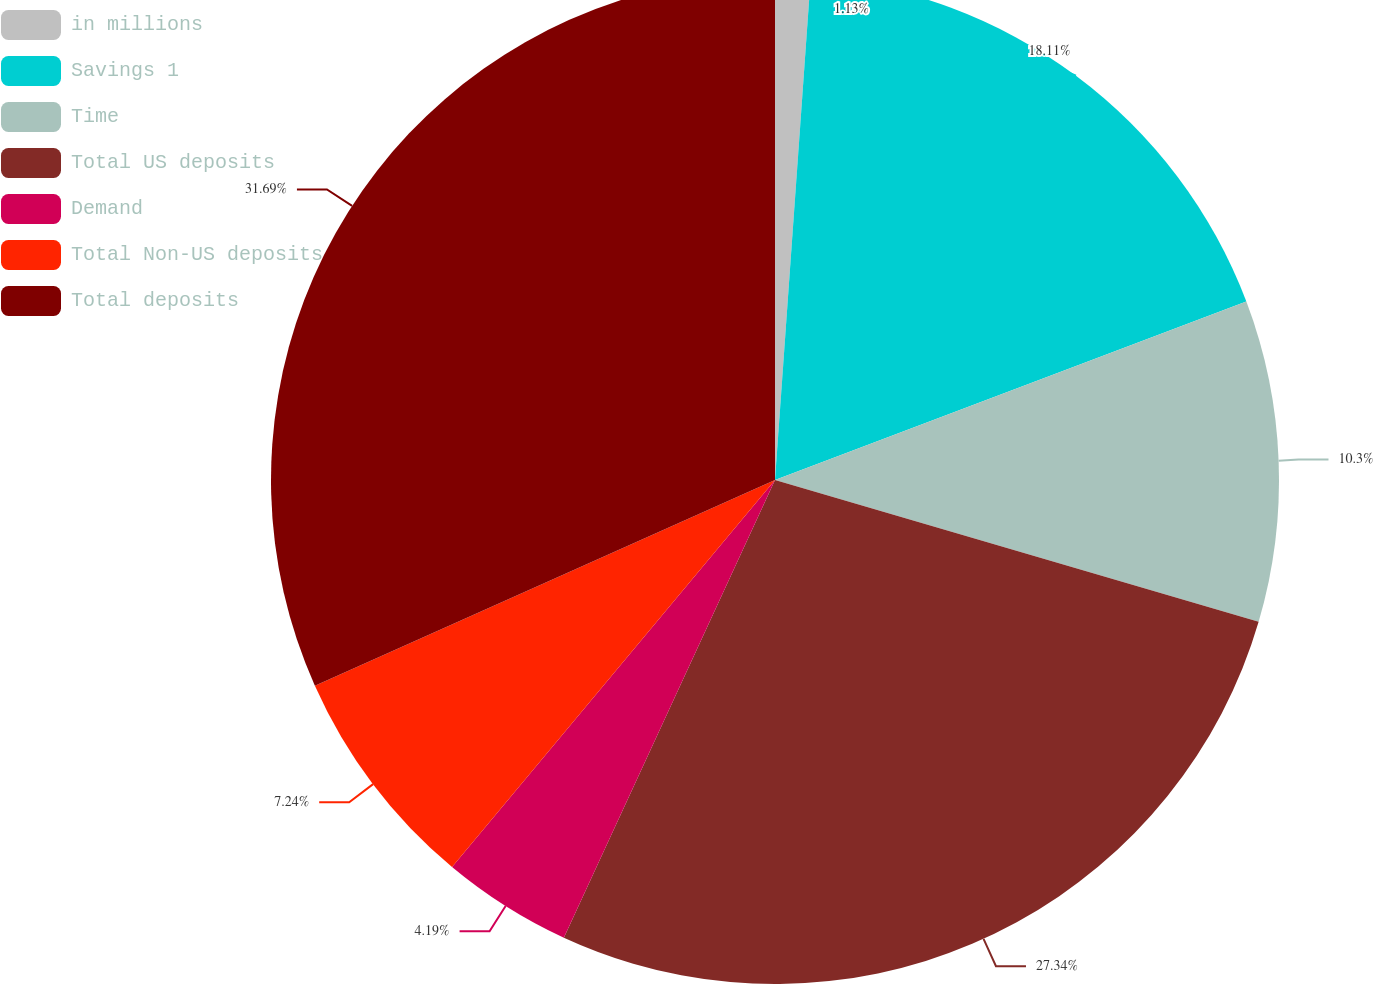<chart> <loc_0><loc_0><loc_500><loc_500><pie_chart><fcel>in millions<fcel>Savings 1<fcel>Time<fcel>Total US deposits<fcel>Demand<fcel>Total Non-US deposits<fcel>Total deposits<nl><fcel>1.13%<fcel>18.11%<fcel>10.3%<fcel>27.34%<fcel>4.19%<fcel>7.24%<fcel>31.69%<nl></chart> 